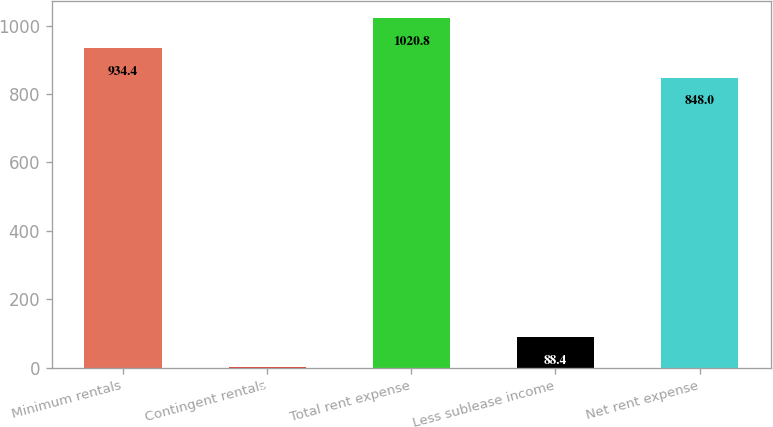<chart> <loc_0><loc_0><loc_500><loc_500><bar_chart><fcel>Minimum rentals<fcel>Contingent rentals<fcel>Total rent expense<fcel>Less sublease income<fcel>Net rent expense<nl><fcel>934.4<fcel>2<fcel>1020.8<fcel>88.4<fcel>848<nl></chart> 